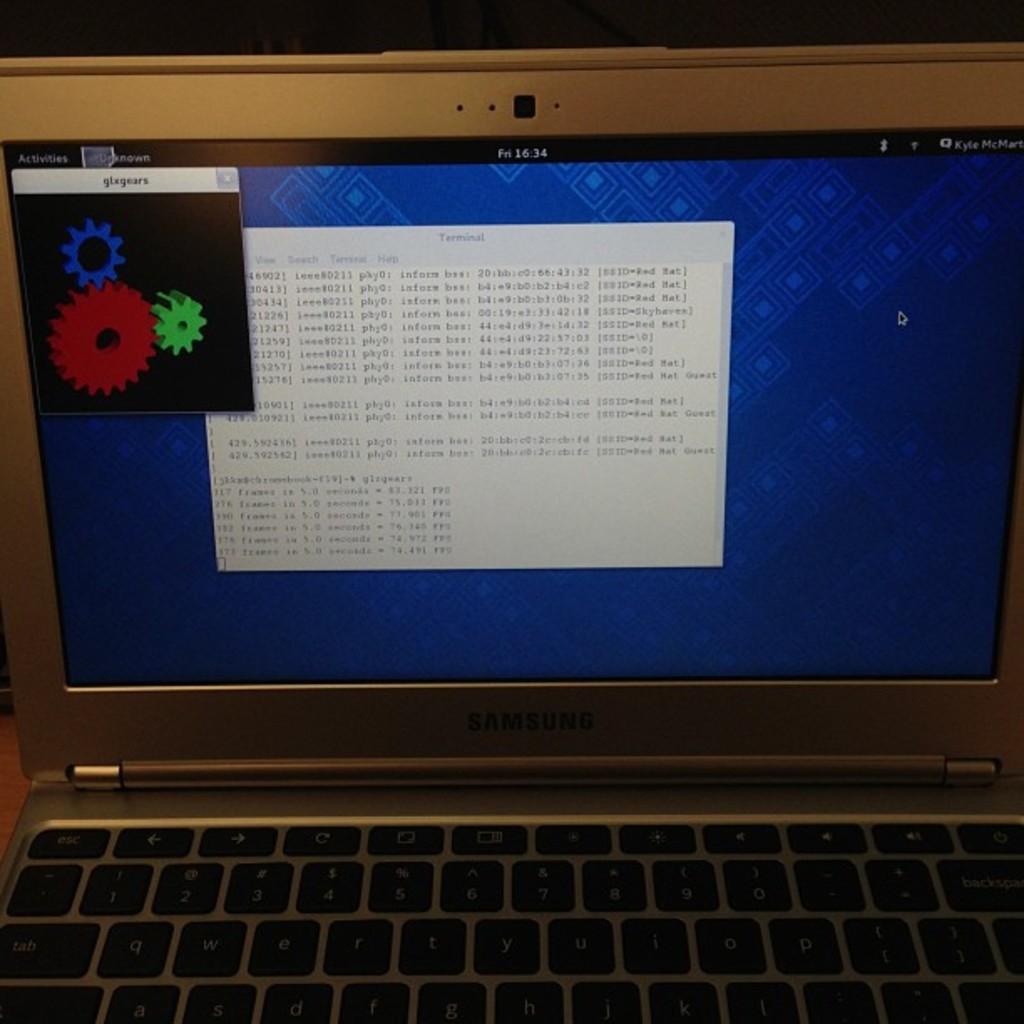What is the brand of this laptop?
Provide a short and direct response. Samsung. What time is it at the top of the screen?
Your answer should be compact. 16:34. 